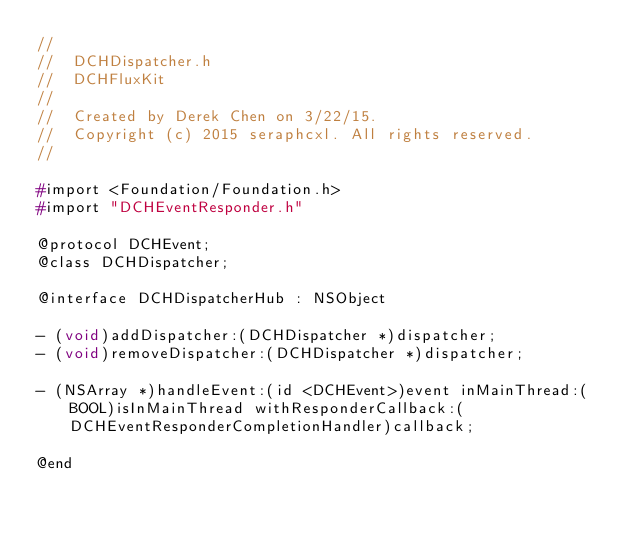Convert code to text. <code><loc_0><loc_0><loc_500><loc_500><_C_>//
//  DCHDispatcher.h
//  DCHFluxKit
//
//  Created by Derek Chen on 3/22/15.
//  Copyright (c) 2015 seraphcxl. All rights reserved.
//

#import <Foundation/Foundation.h>
#import "DCHEventResponder.h"

@protocol DCHEvent;
@class DCHDispatcher;

@interface DCHDispatcherHub : NSObject

- (void)addDispatcher:(DCHDispatcher *)dispatcher;
- (void)removeDispatcher:(DCHDispatcher *)dispatcher;

- (NSArray *)handleEvent:(id <DCHEvent>)event inMainThread:(BOOL)isInMainThread withResponderCallback:(DCHEventResponderCompletionHandler)callback;

@end
</code> 